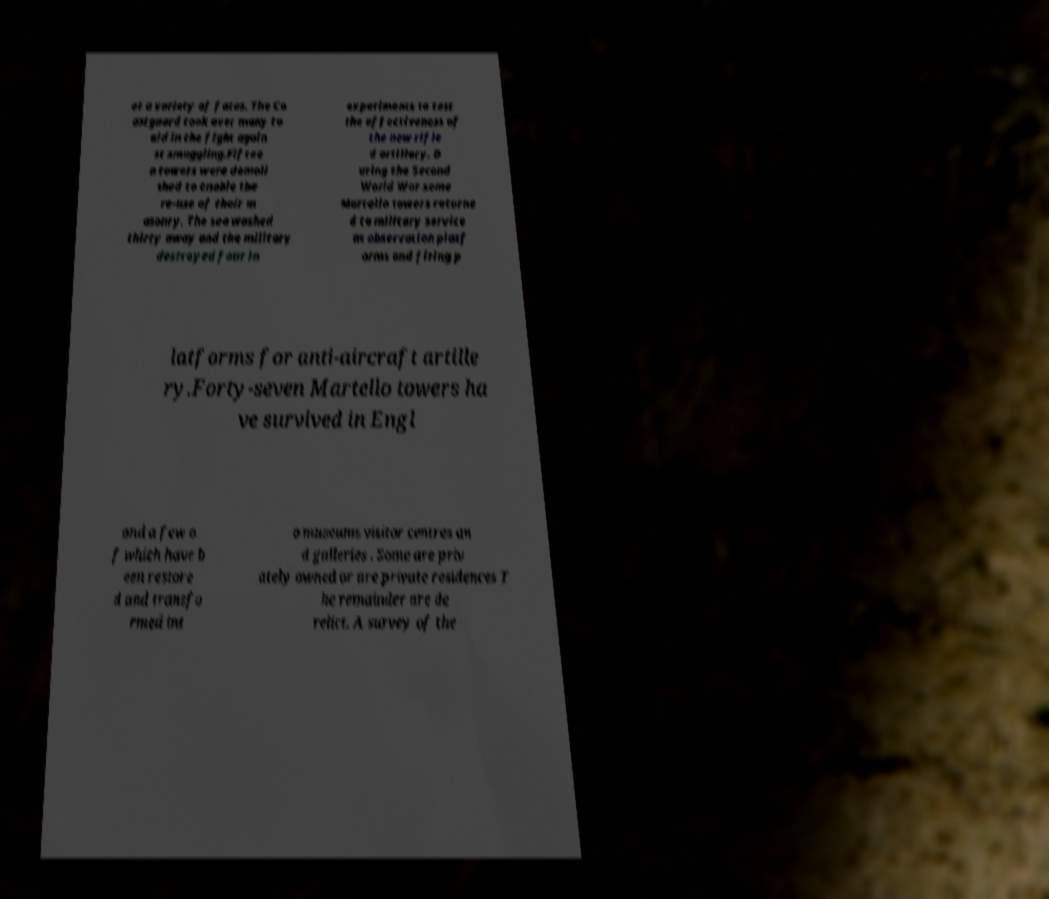For documentation purposes, I need the text within this image transcribed. Could you provide that? et a variety of fates. The Co astguard took over many to aid in the fight again st smuggling.Fiftee n towers were demoli shed to enable the re-use of their m asonry. The sea washed thirty away and the military destroyed four in experiments to test the effectiveness of the new rifle d artillery. D uring the Second World War some Martello towers returne d to military service as observation platf orms and firing p latforms for anti-aircraft artille ry.Forty-seven Martello towers ha ve survived in Engl and a few o f which have b een restore d and transfo rmed int o museums visitor centres an d galleries . Some are priv ately owned or are private residences T he remainder are de relict. A survey of the 